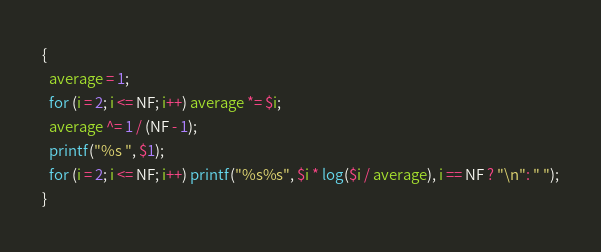<code> <loc_0><loc_0><loc_500><loc_500><_Awk_>{
  average = 1;
  for (i = 2; i <= NF; i++) average *= $i;
  average ^= 1 / (NF - 1);
  printf("%s ", $1);
  for (i = 2; i <= NF; i++) printf("%s%s", $i * log($i / average), i == NF ? "\n": " ");
}
</code> 